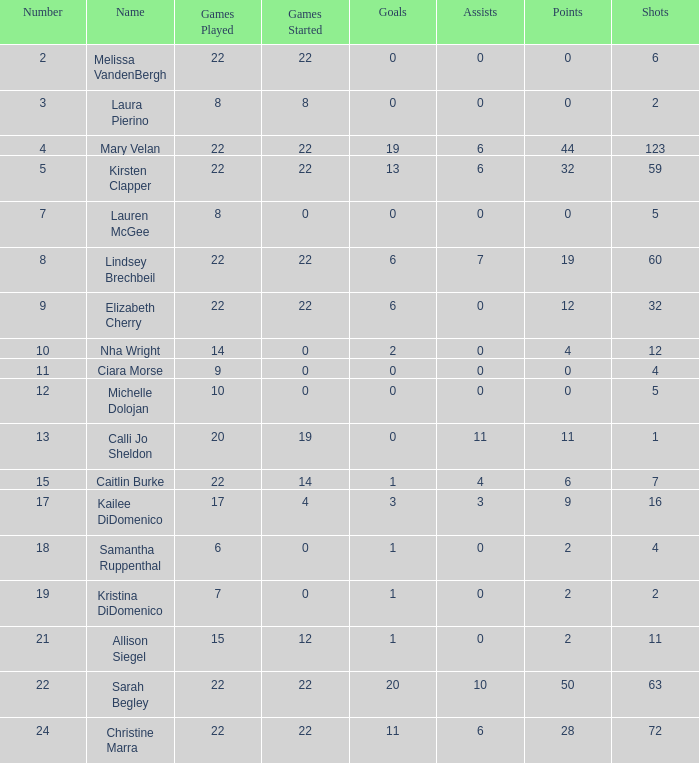How many digits are attributed to the player with 10 assists? 1.0. 